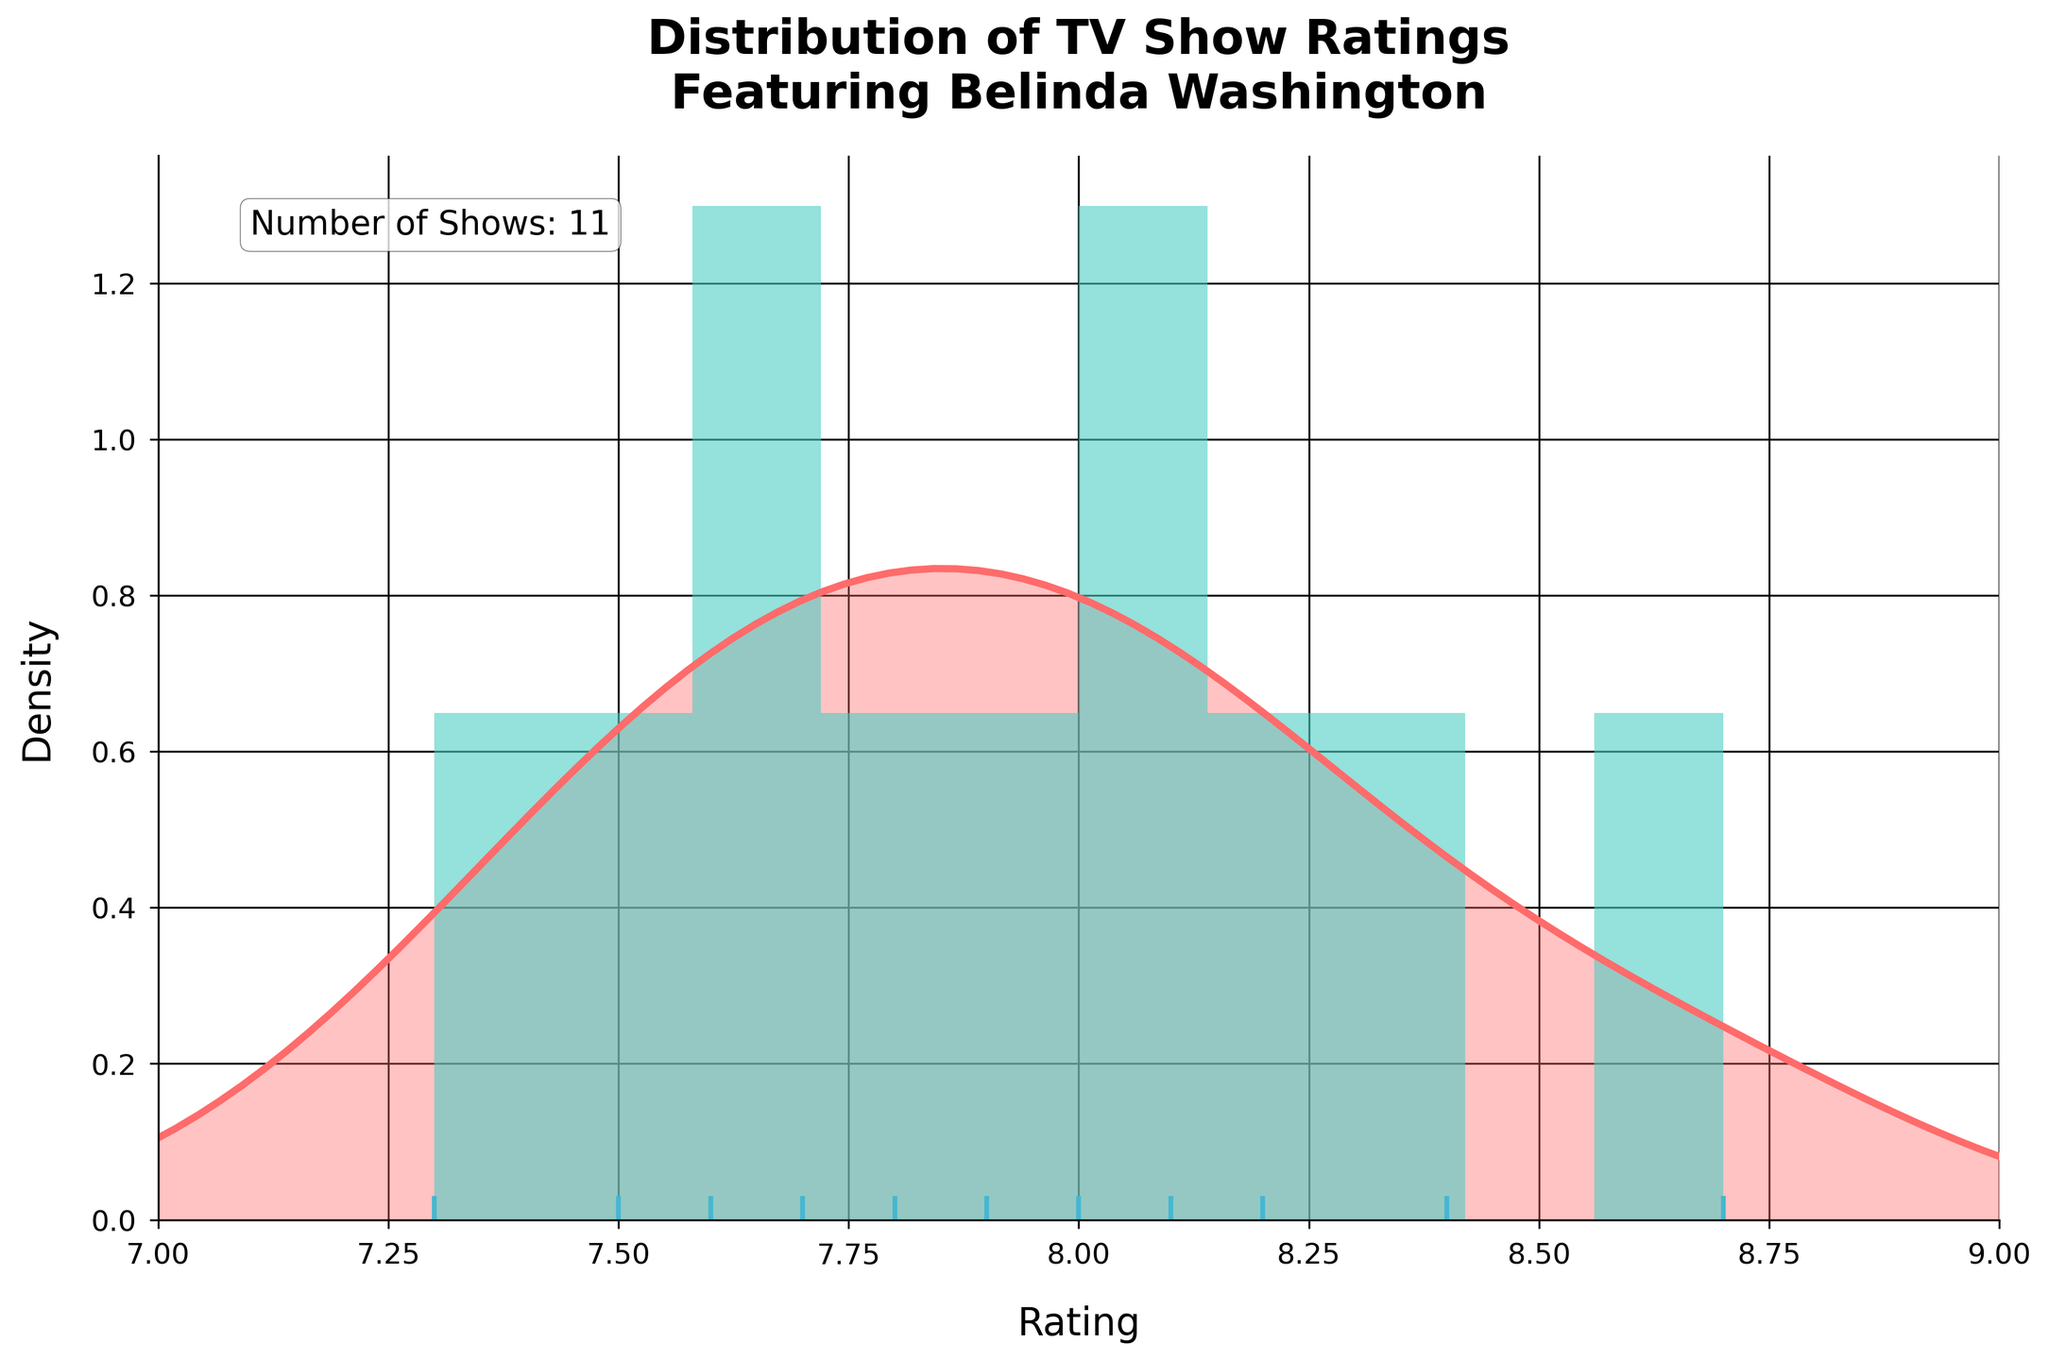What's the title of the plot? The title is displayed prominently at the top of the figure and reads "Distribution of TV Show Ratings Featuring Belinda Washington."
Answer: Distribution of TV Show Ratings Featuring Belinda Washington What is the range of the x-axis? The x-axis range can be observed at the bottom of the plot. The axis starts at 7 and ends at 9.
Answer: 7 to 9 How many TV shows are featured in the plot? The number of shows is annotated in text on the top-left part of the figure, saying "Number of Shows: 11."
Answer: 11 Which TV show has the highest rating? In the rug plot at the bottom of the figure, individual ratings are plotted as vertical lines. The show with the highest rating is the one at the farthest right position, corresponding to a rating of 8.7.
Answer: Hearts Unfold What color is used for the histogram bars? The color of the histogram bars can be seen in the plot itself and is some shade of teal.
Answer: Teal What is the approximate location of the highest density peak in the KDE plot? The highest density peak in the KDE plot appears where the density curve reaches its maximum height, which looks around a rating of 8.0-8.2.
Answer: Around 8.0-8.2 What's the range of ratings for the majority of the TV shows? By observing the histogram and KDE plot, most ratings fall between 7.5 and 8.3 based on their density.
Answer: 7.5—8.3 How does the density of shows with a rating of 7.3 compare to shows with a rating of 8.4? The density at 7.3 (Dream Horizons) is lower than the density at 8.4 (Laughing Legends) as seen in the KDE plot. The plot shows lower peaks at 7.3 and higher peaks around 8.4.
Answer: Density at 7.3 is lower than at 8.4 How does the number of TV shows rated above 8 compare to those rated below 8? Count the TV shows with ratings above and below 8. According to visual inspection, there are 5 shows with ratings above 8 and 6 shows with ratings below 8.
Answer: 5 shows above 8, 6 shows below 8 What percentage of the TV shows have a rating of 8 or above? Count the shows with ratings of 8 or above (5) and divide by the total number of shows (11), then multiply by 100 to convert to percentage.
Answer: Approximately 45.5% 